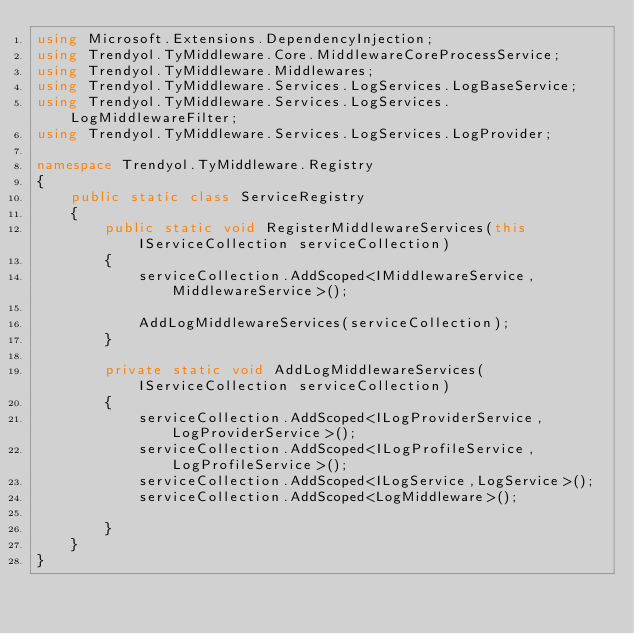<code> <loc_0><loc_0><loc_500><loc_500><_C#_>using Microsoft.Extensions.DependencyInjection;
using Trendyol.TyMiddleware.Core.MiddlewareCoreProcessService;
using Trendyol.TyMiddleware.Middlewares;
using Trendyol.TyMiddleware.Services.LogServices.LogBaseService;
using Trendyol.TyMiddleware.Services.LogServices.LogMiddlewareFilter;
using Trendyol.TyMiddleware.Services.LogServices.LogProvider;

namespace Trendyol.TyMiddleware.Registry
{
    public static class ServiceRegistry
    {
        public static void RegisterMiddlewareServices(this IServiceCollection serviceCollection)
        {
            serviceCollection.AddScoped<IMiddlewareService, MiddlewareService>();
            
            AddLogMiddlewareServices(serviceCollection);
        }

        private static void AddLogMiddlewareServices(IServiceCollection serviceCollection)
        {
            serviceCollection.AddScoped<ILogProviderService, LogProviderService>();
            serviceCollection.AddScoped<ILogProfileService, LogProfileService>();
            serviceCollection.AddScoped<ILogService,LogService>();
            serviceCollection.AddScoped<LogMiddleware>();
            
        }
    }
}</code> 